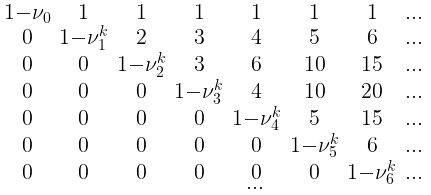<formula> <loc_0><loc_0><loc_500><loc_500>\begin{smallmatrix} 1 - \nu _ { 0 } & 1 & 1 & 1 & 1 & 1 & 1 & \dots \\ 0 & 1 - \nu _ { 1 } ^ { k } & 2 & 3 & 4 & 5 & 6 & \dots \\ 0 & 0 & 1 - \nu _ { 2 } ^ { k } & 3 & 6 & 1 0 & 1 5 & \dots \\ 0 & 0 & 0 & 1 - \nu _ { 3 } ^ { k } & 4 & 1 0 & 2 0 & \dots \\ 0 & 0 & 0 & 0 & 1 - \nu _ { 4 } ^ { k } & 5 & 1 5 & \dots \\ 0 & 0 & 0 & 0 & 0 & 1 - \nu _ { 5 } ^ { k } & 6 & \dots \\ 0 & 0 & 0 & 0 & 0 & 0 & 1 - \nu _ { 6 } ^ { k } & \dots \\ & & & & \dots & & & \\ \end{smallmatrix}</formula> 